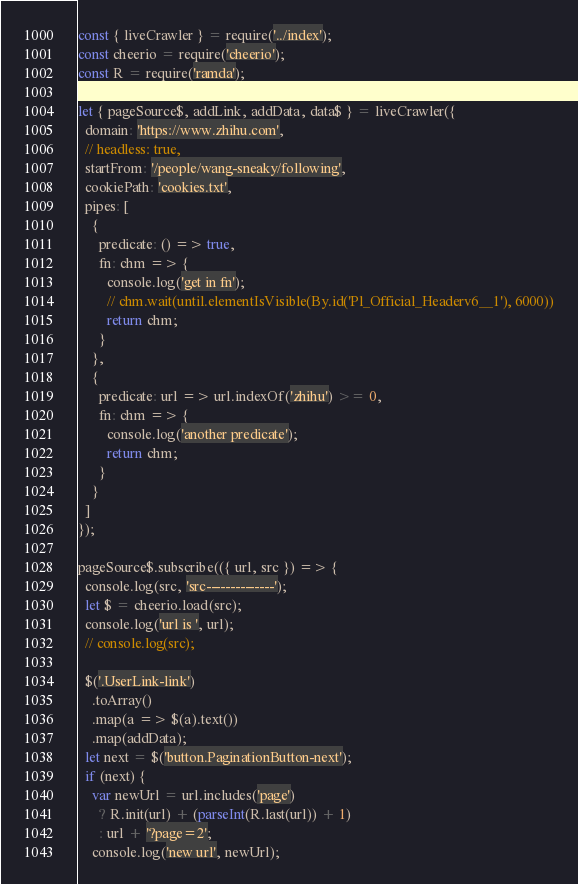<code> <loc_0><loc_0><loc_500><loc_500><_JavaScript_>const { liveCrawler } = require('../index');
const cheerio = require('cheerio');
const R = require('ramda');

let { pageSource$, addLink, addData, data$ } = liveCrawler({
  domain: 'https://www.zhihu.com',
  // headless: true,
  startFrom: '/people/wang-sneaky/following',
  cookiePath: 'cookies.txt',
  pipes: [
    {
      predicate: () => true,
      fn: chm => {
        console.log('get in fn');
        // chm.wait(until.elementIsVisible(By.id('Pl_Official_Headerv6__1'), 6000))
        return chm;
      }
    },
    {
      predicate: url => url.indexOf('zhihu') >= 0,
      fn: chm => {
        console.log('another predicate');
        return chm;
      }
    }
  ]
});

pageSource$.subscribe(({ url, src }) => {
  console.log(src, 'src--------------');
  let $ = cheerio.load(src);
  console.log('url is ', url);
  // console.log(src);

  $('.UserLink-link')
    .toArray()
    .map(a => $(a).text())
    .map(addData);
  let next = $('button.PaginationButton-next');
  if (next) {
    var newUrl = url.includes('page')
      ? R.init(url) + (parseInt(R.last(url)) + 1)
      : url + '?page=2';
    console.log('new url', newUrl);</code> 